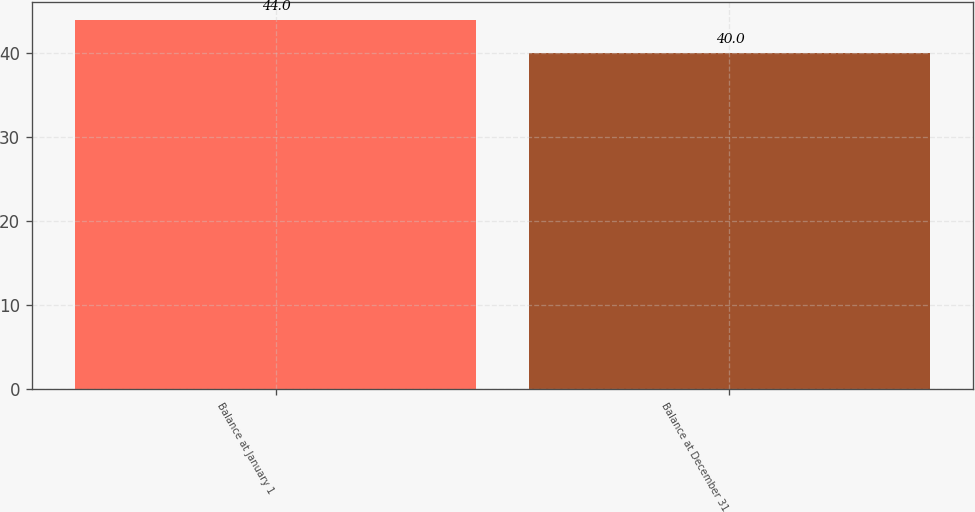<chart> <loc_0><loc_0><loc_500><loc_500><bar_chart><fcel>Balance at January 1<fcel>Balance at December 31<nl><fcel>44<fcel>40<nl></chart> 